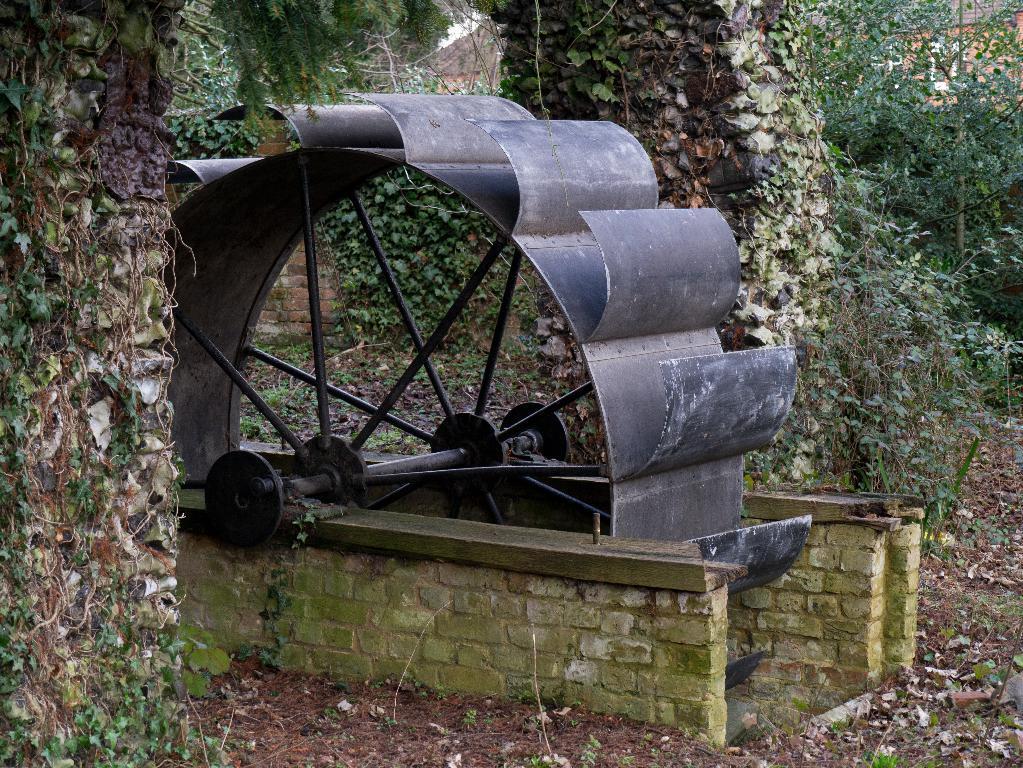Could you give a brief overview of what you see in this image? In this image I can see the machine which is in grey color. In the background I can see many trees and the ground. 